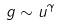<formula> <loc_0><loc_0><loc_500><loc_500>g \sim u ^ { \gamma }</formula> 